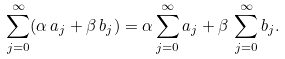Convert formula to latex. <formula><loc_0><loc_0><loc_500><loc_500>\sum _ { j = 0 } ^ { \infty } ( \alpha \, a _ { j } + \beta \, b _ { j } ) = \alpha \sum _ { j = 0 } ^ { \infty } a _ { j } + \beta \, \sum _ { j = 0 } ^ { \infty } b _ { j } .</formula> 